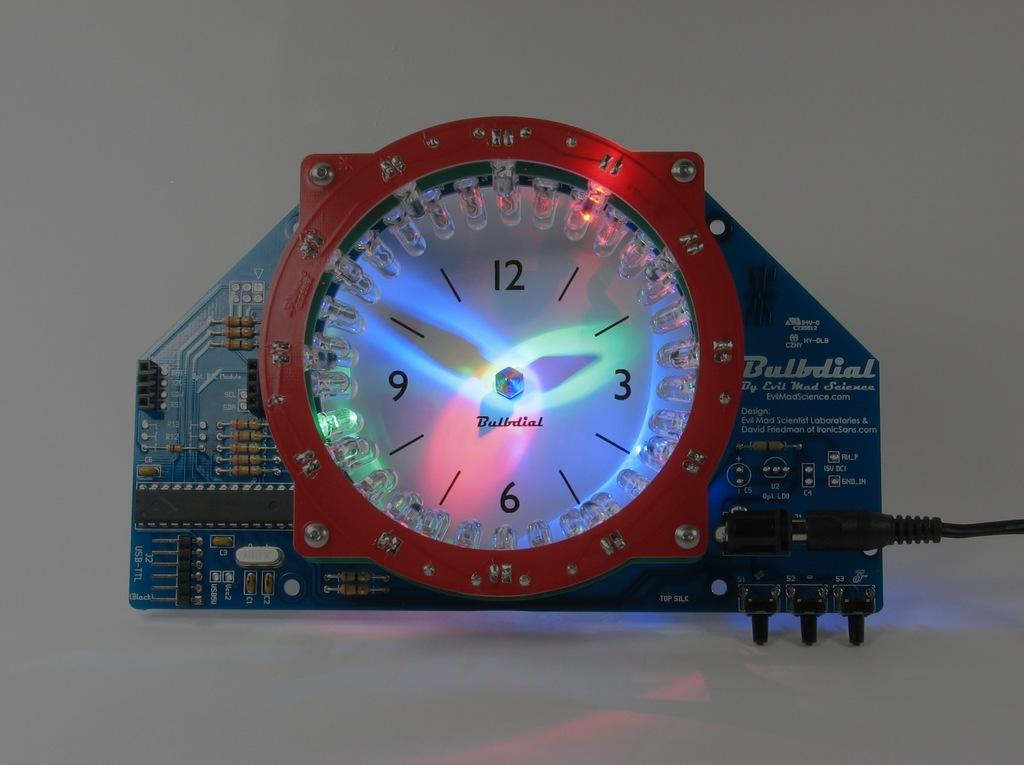Provide a one-sentence caption for the provided image. A Bulbdial clock has bright lights on the face. 